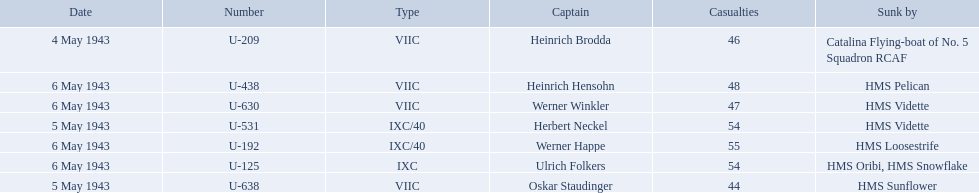Which were the names of the sinkers of the convoys? Catalina Flying-boat of No. 5 Squadron RCAF, HMS Sunflower, HMS Vidette, HMS Loosestrife, HMS Oribi, HMS Snowflake, HMS Vidette, HMS Pelican. What captain was sunk by the hms pelican? Heinrich Hensohn. 